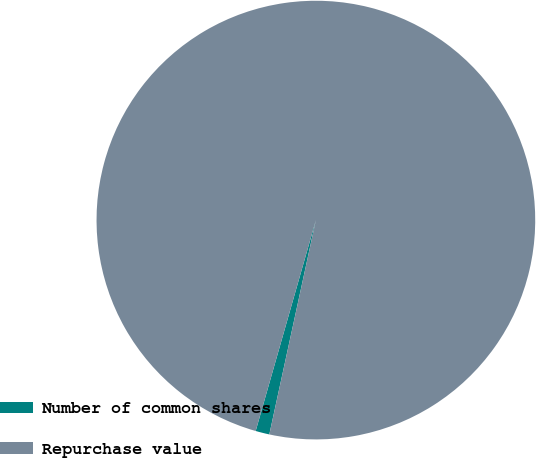Convert chart to OTSL. <chart><loc_0><loc_0><loc_500><loc_500><pie_chart><fcel>Number of common shares<fcel>Repurchase value<nl><fcel>1.02%<fcel>98.98%<nl></chart> 